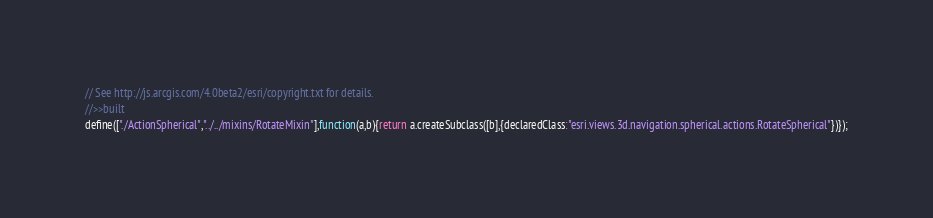<code> <loc_0><loc_0><loc_500><loc_500><_JavaScript_>// See http://js.arcgis.com/4.0beta2/esri/copyright.txt for details.
//>>built
define(["./ActionSpherical","../../mixins/RotateMixin"],function(a,b){return a.createSubclass([b],{declaredClass:"esri.views.3d.navigation.spherical.actions.RotateSpherical"})});</code> 